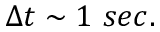Convert formula to latex. <formula><loc_0><loc_0><loc_500><loc_500>\Delta t \sim 1 \ s e c .</formula> 